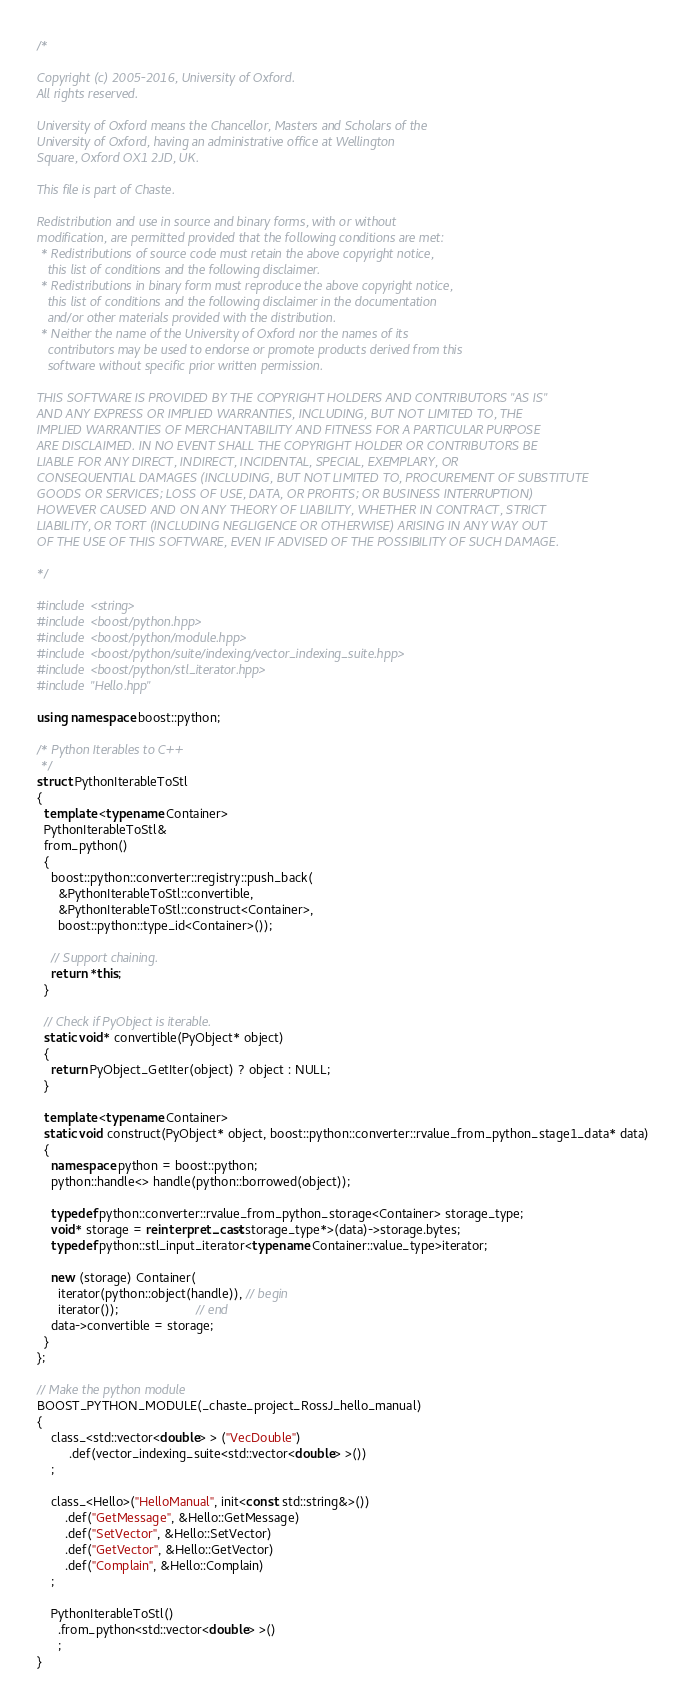<code> <loc_0><loc_0><loc_500><loc_500><_C++_>/*

Copyright (c) 2005-2016, University of Oxford.
All rights reserved.

University of Oxford means the Chancellor, Masters and Scholars of the
University of Oxford, having an administrative office at Wellington
Square, Oxford OX1 2JD, UK.

This file is part of Chaste.

Redistribution and use in source and binary forms, with or without
modification, are permitted provided that the following conditions are met:
 * Redistributions of source code must retain the above copyright notice,
   this list of conditions and the following disclaimer.
 * Redistributions in binary form must reproduce the above copyright notice,
   this list of conditions and the following disclaimer in the documentation
   and/or other materials provided with the distribution.
 * Neither the name of the University of Oxford nor the names of its
   contributors may be used to endorse or promote products derived from this
   software without specific prior written permission.

THIS SOFTWARE IS PROVIDED BY THE COPYRIGHT HOLDERS AND CONTRIBUTORS "AS IS"
AND ANY EXPRESS OR IMPLIED WARRANTIES, INCLUDING, BUT NOT LIMITED TO, THE
IMPLIED WARRANTIES OF MERCHANTABILITY AND FITNESS FOR A PARTICULAR PURPOSE
ARE DISCLAIMED. IN NO EVENT SHALL THE COPYRIGHT HOLDER OR CONTRIBUTORS BE
LIABLE FOR ANY DIRECT, INDIRECT, INCIDENTAL, SPECIAL, EXEMPLARY, OR
CONSEQUENTIAL DAMAGES (INCLUDING, BUT NOT LIMITED TO, PROCUREMENT OF SUBSTITUTE
GOODS OR SERVICES; LOSS OF USE, DATA, OR PROFITS; OR BUSINESS INTERRUPTION)
HOWEVER CAUSED AND ON ANY THEORY OF LIABILITY, WHETHER IN CONTRACT, STRICT
LIABILITY, OR TORT (INCLUDING NEGLIGENCE OR OTHERWISE) ARISING IN ANY WAY OUT
OF THE USE OF THIS SOFTWARE, EVEN IF ADVISED OF THE POSSIBILITY OF SUCH DAMAGE.

*/

#include <string>
#include <boost/python.hpp>
#include <boost/python/module.hpp>
#include <boost/python/suite/indexing/vector_indexing_suite.hpp>
#include <boost/python/stl_iterator.hpp>
#include "Hello.hpp"

using namespace boost::python;

/* Python Iterables to C++
 */
struct PythonIterableToStl
{
  template <typename Container>
  PythonIterableToStl&
  from_python()
  {
    boost::python::converter::registry::push_back(
      &PythonIterableToStl::convertible,
      &PythonIterableToStl::construct<Container>,
      boost::python::type_id<Container>());

    // Support chaining.
    return *this;
  }

  // Check if PyObject is iterable.
  static void* convertible(PyObject* object)
  {
    return PyObject_GetIter(object) ? object : NULL;
  }

  template <typename Container>
  static void construct(PyObject* object, boost::python::converter::rvalue_from_python_stage1_data* data)
  {
    namespace python = boost::python;
    python::handle<> handle(python::borrowed(object));

    typedef python::converter::rvalue_from_python_storage<Container> storage_type;
    void* storage = reinterpret_cast<storage_type*>(data)->storage.bytes;
    typedef python::stl_input_iterator<typename Container::value_type>iterator;

    new (storage) Container(
      iterator(python::object(handle)), // begin
      iterator());                      // end
    data->convertible = storage;
  }
};

// Make the python module
BOOST_PYTHON_MODULE(_chaste_project_RossJ_hello_manual)
{
    class_<std::vector<double> > ("VecDouble")
         .def(vector_indexing_suite<std::vector<double> >())
    ;

    class_<Hello>("HelloManual", init<const std::string&>())
        .def("GetMessage", &Hello::GetMessage)
        .def("SetVector", &Hello::SetVector)
        .def("GetVector", &Hello::GetVector)
        .def("Complain", &Hello::Complain)
    ;

    PythonIterableToStl()
      .from_python<std::vector<double> >()
      ;
}
</code> 